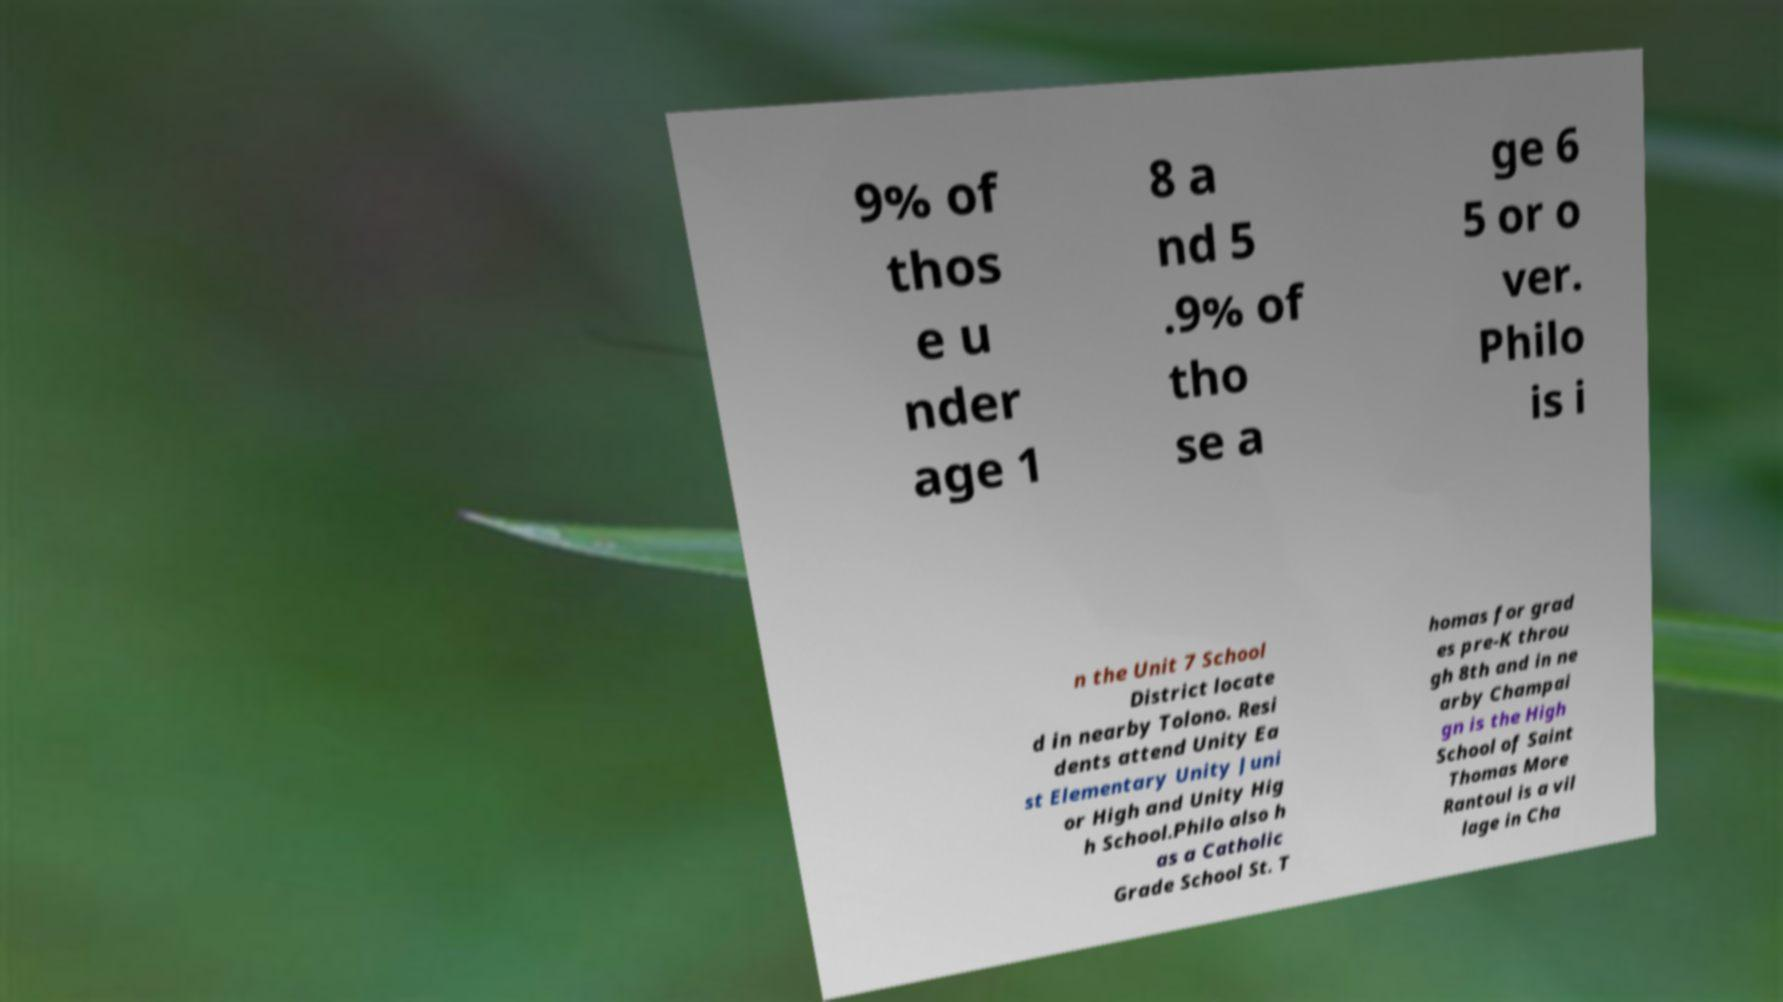Please read and relay the text visible in this image. What does it say? 9% of thos e u nder age 1 8 a nd 5 .9% of tho se a ge 6 5 or o ver. Philo is i n the Unit 7 School District locate d in nearby Tolono. Resi dents attend Unity Ea st Elementary Unity Juni or High and Unity Hig h School.Philo also h as a Catholic Grade School St. T homas for grad es pre-K throu gh 8th and in ne arby Champai gn is the High School of Saint Thomas More Rantoul is a vil lage in Cha 